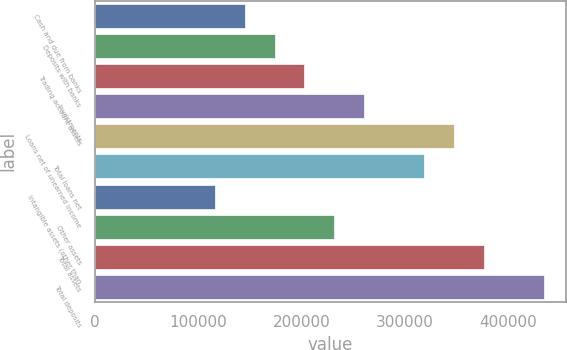<chart> <loc_0><loc_0><loc_500><loc_500><bar_chart><fcel>Cash and due from banks<fcel>Deposits with banks<fcel>Trading account assets<fcel>Investments<fcel>Loans net of unearned income<fcel>Total loans net<fcel>Intangible assets (other than<fcel>Other assets<fcel>Total assets<fcel>Total deposits<nl><fcel>144953<fcel>173906<fcel>202859<fcel>260766<fcel>347625<fcel>318672<fcel>116000<fcel>231813<fcel>376579<fcel>434485<nl></chart> 